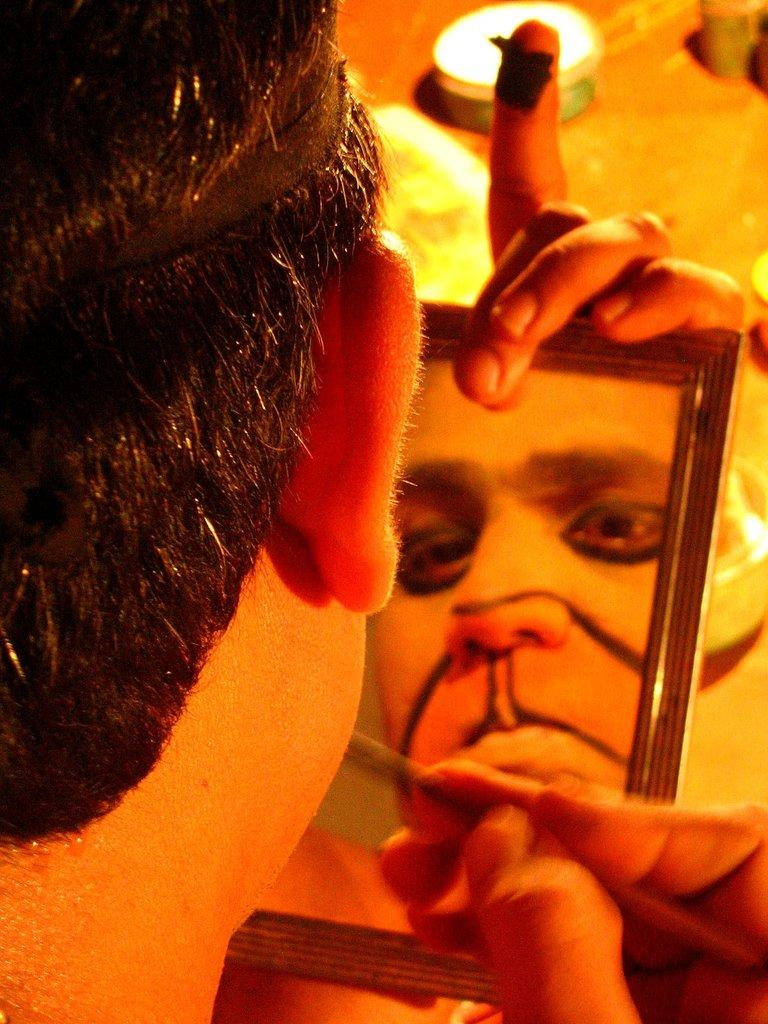What is the main subject of the image? There is a person in the image. What is the person holding in their hands? The person is holding a brush in their hands. Can you describe any other elements in the image? The person's reflection is visible in a mirror. What type of iron can be seen in the image? There is no iron present in the image. How many weeks can be seen in the image? There is no reference to weeks in the image. What type of clouds can be seen in the image? There is no mention of clouds in the image. 